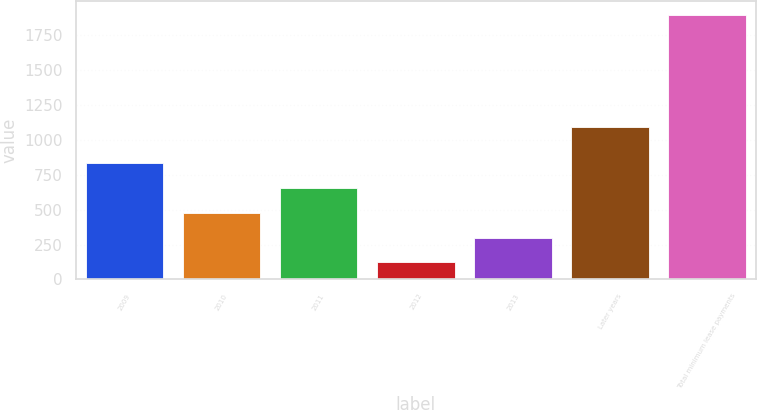<chart> <loc_0><loc_0><loc_500><loc_500><bar_chart><fcel>2009<fcel>2010<fcel>2011<fcel>2012<fcel>2013<fcel>Later years<fcel>Total minimum lease payments<nl><fcel>832.4<fcel>477.2<fcel>654.8<fcel>122<fcel>299.6<fcel>1090<fcel>1898<nl></chart> 